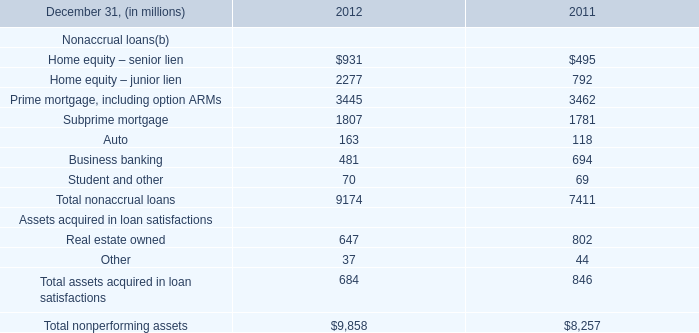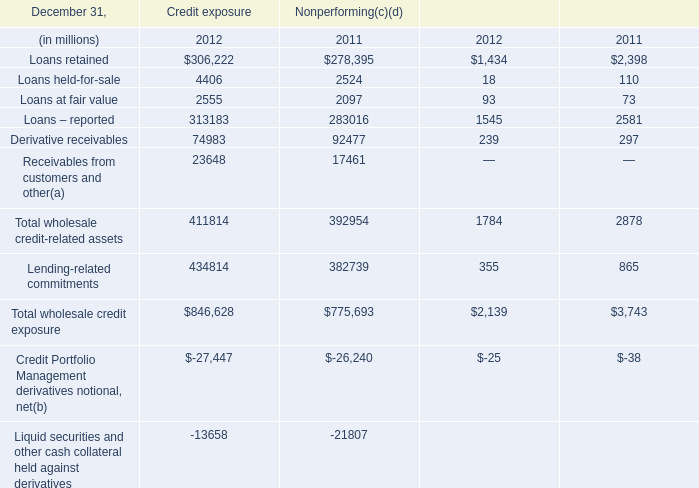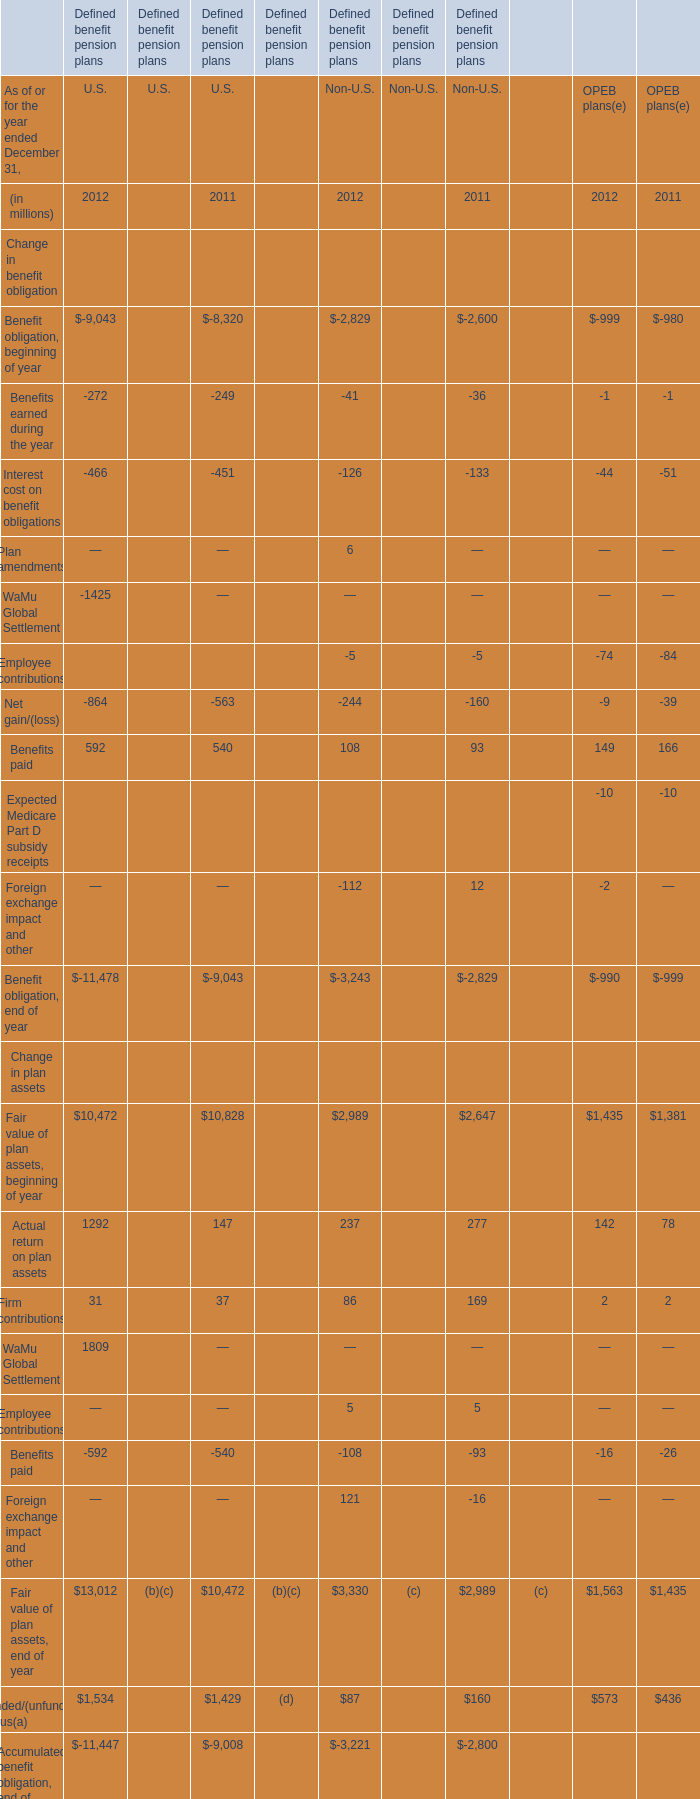What is the percentage of Firm contributions in relation to the total in 2011 for U.S? 
Computations: (37 / 10828)
Answer: 0.00342. 